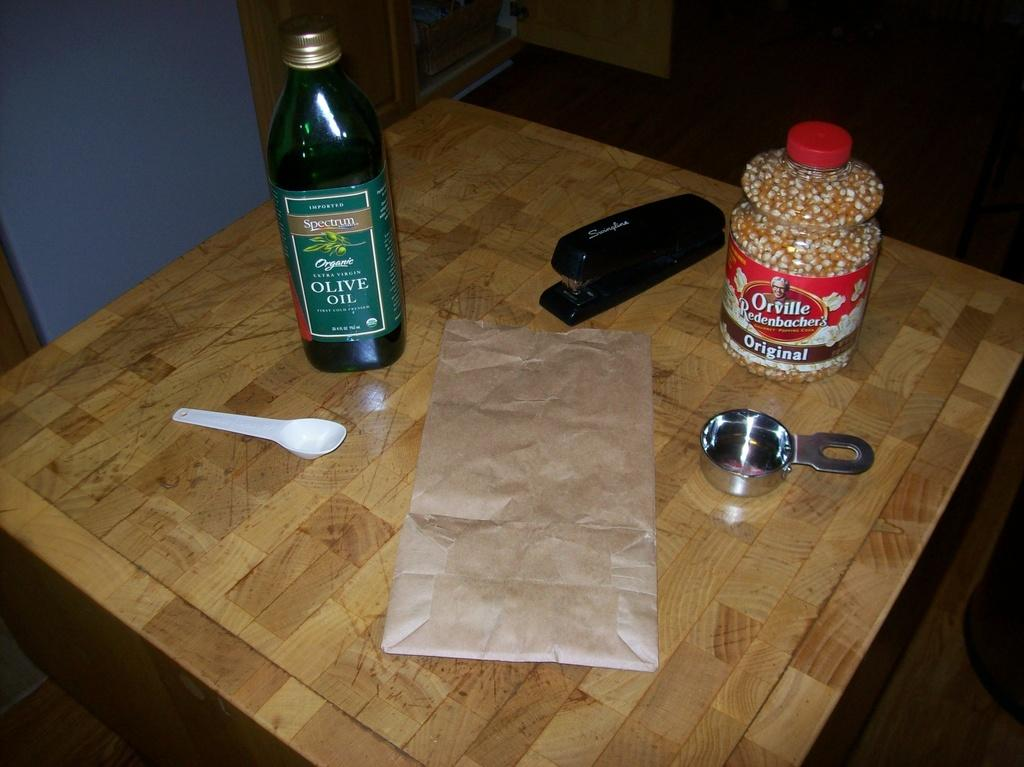What is one item visible in the image? There is a bottle in the image. What else can be seen in the image? There is a spoon in the image. Where are these items located? They are on the table in the image. What type of cheese is being served on the pet's toys in the image? There is no cheese or pet's toys present in the image; it only features a bottle and a spoon on a table. 